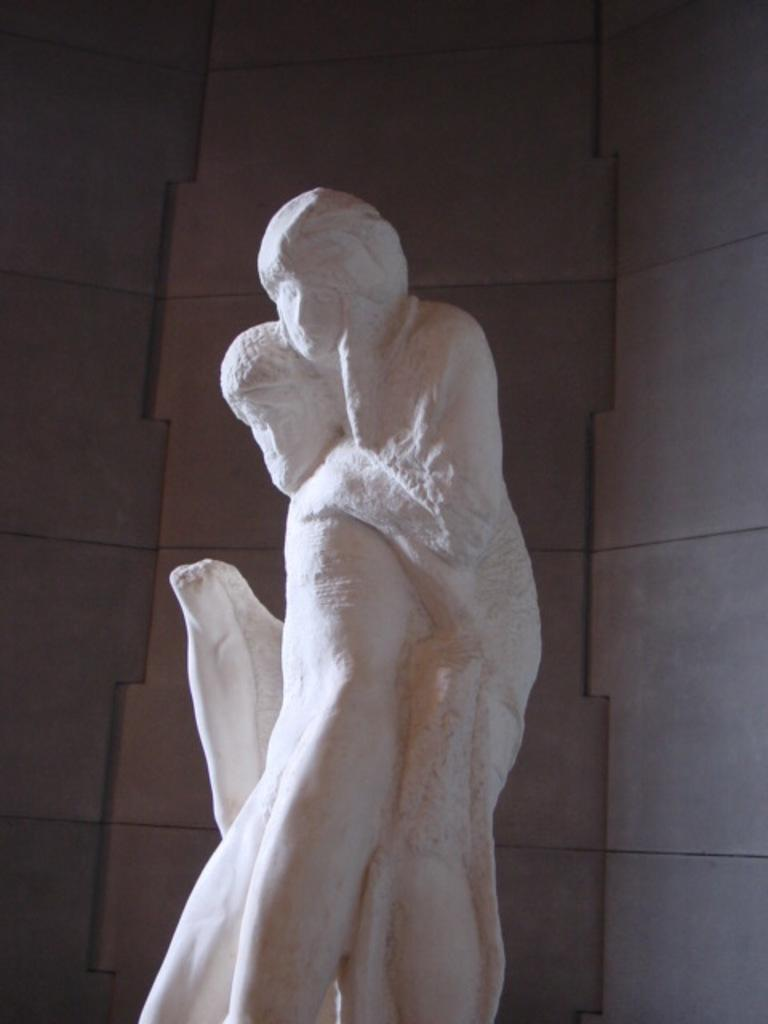What is the main subject of the image? There is a sculpture in the image. What color is the sculpture? The sculpture is white in color. What can be seen in the background of the image? There is a wall in the background of the image. What type of game is being played in the image? There is no game present in the image; it features a white sculpture and a wall in the background. What material is the sculpture made of? The provided facts do not mention the material of the sculpture, so we cannot determine if it is made of stone or any other material. 